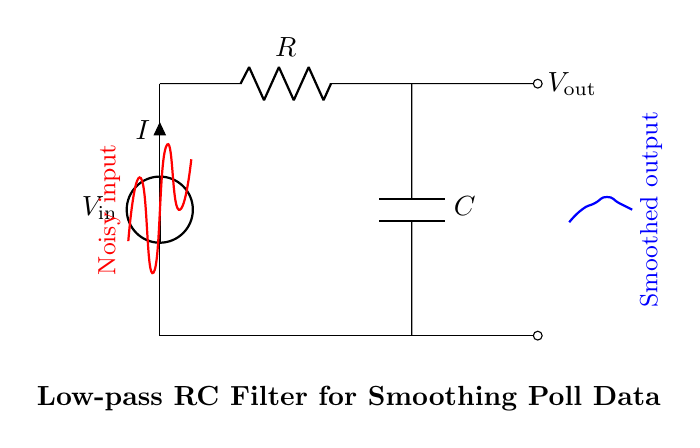What is the input voltage in the circuit? The input voltage is labeled as V_in at the top left of the circuit diagram, where the voltage source is connected.
Answer: V_in What components are present in the circuit? The circuit contains a voltage source, a resistor, and a capacitor, which are essential components used in the low-pass filter configuration.
Answer: Voltage source, resistor, capacitor What is the purpose of the capacitor in this circuit? The capacitor in this low-pass filter smooths the output signal by charging and discharging, effectively filtering out high-frequency noise and allowing lower-frequency signals to pass through.
Answer: Smoothing output What is the output voltage labeled in the circuit? The output voltage is labeled as V_out, which is taken from the junction between the resistor and the capacitor.
Answer: V_out How does the low-pass filter affect the noisy input signal? The low-pass filter attenuates high-frequency components of the noisy input signal, resulting in a smoother output signal that more accurately represents the underlying data trend in the poll responses.
Answer: Attenuates high frequency What happens to the output voltage when the resistor value is increased? Increasing the resistor value will result in a lower cutoff frequency, which means the filter will allow fewer high-frequency signals to pass through, leading to a smoother output signal at lower frequencies.
Answer: Smoother output voltage What type of filter is this circuit classified as? This circuit is classified as a low-pass filter, specifically an RC low-pass filter, because it allows low-frequency signals to pass while blocking higher-frequency signals.
Answer: Low-pass filter 